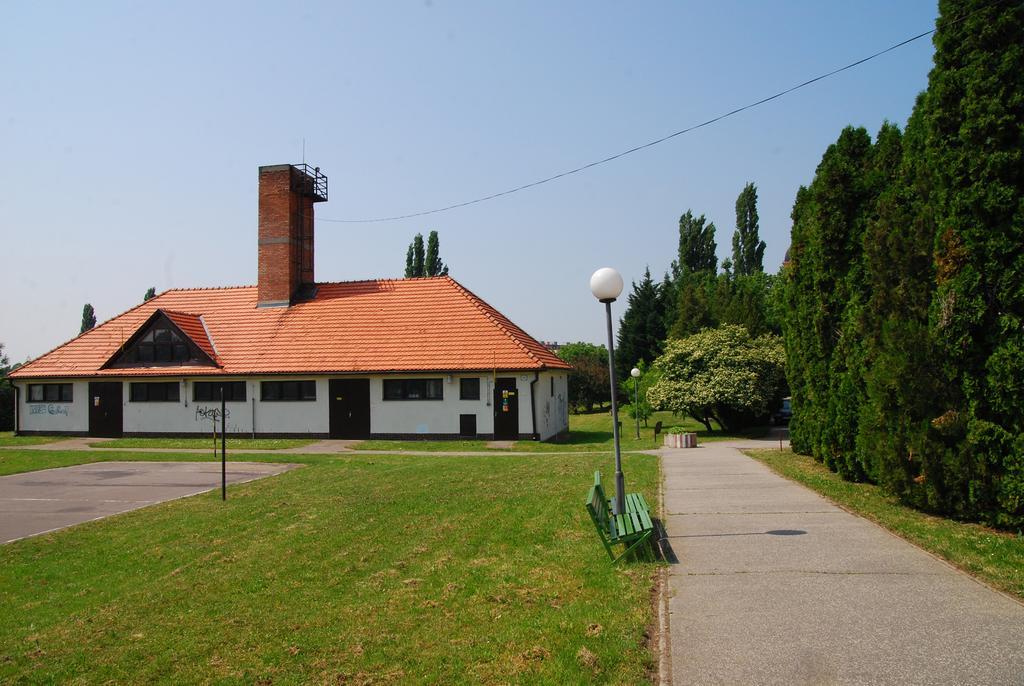How would you summarize this image in a sentence or two? In this picture there is a house on the left side of the image and there is grass land at the bottom side of the image and there are trees on the right side of the image, there is a pole and a bench in the image. 